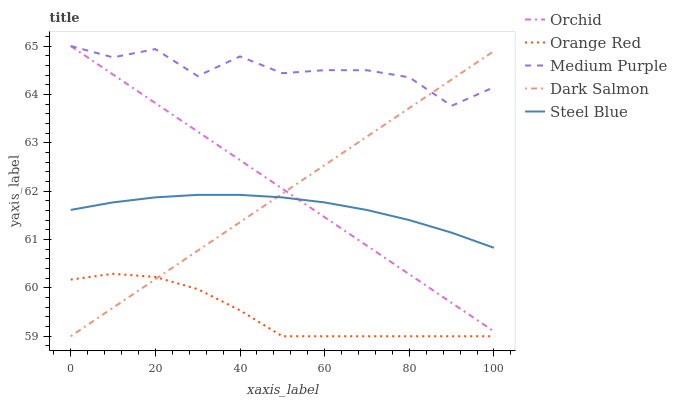Does Orange Red have the minimum area under the curve?
Answer yes or no. Yes. Does Medium Purple have the maximum area under the curve?
Answer yes or no. Yes. Does Steel Blue have the minimum area under the curve?
Answer yes or no. No. Does Steel Blue have the maximum area under the curve?
Answer yes or no. No. Is Dark Salmon the smoothest?
Answer yes or no. Yes. Is Medium Purple the roughest?
Answer yes or no. Yes. Is Steel Blue the smoothest?
Answer yes or no. No. Is Steel Blue the roughest?
Answer yes or no. No. Does Dark Salmon have the lowest value?
Answer yes or no. Yes. Does Steel Blue have the lowest value?
Answer yes or no. No. Does Orchid have the highest value?
Answer yes or no. Yes. Does Steel Blue have the highest value?
Answer yes or no. No. Is Orange Red less than Medium Purple?
Answer yes or no. Yes. Is Medium Purple greater than Steel Blue?
Answer yes or no. Yes. Does Dark Salmon intersect Orchid?
Answer yes or no. Yes. Is Dark Salmon less than Orchid?
Answer yes or no. No. Is Dark Salmon greater than Orchid?
Answer yes or no. No. Does Orange Red intersect Medium Purple?
Answer yes or no. No. 